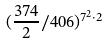<formula> <loc_0><loc_0><loc_500><loc_500>( \frac { 3 7 4 } { 2 } / 4 0 6 ) ^ { 7 ^ { 2 } \cdot 2 }</formula> 